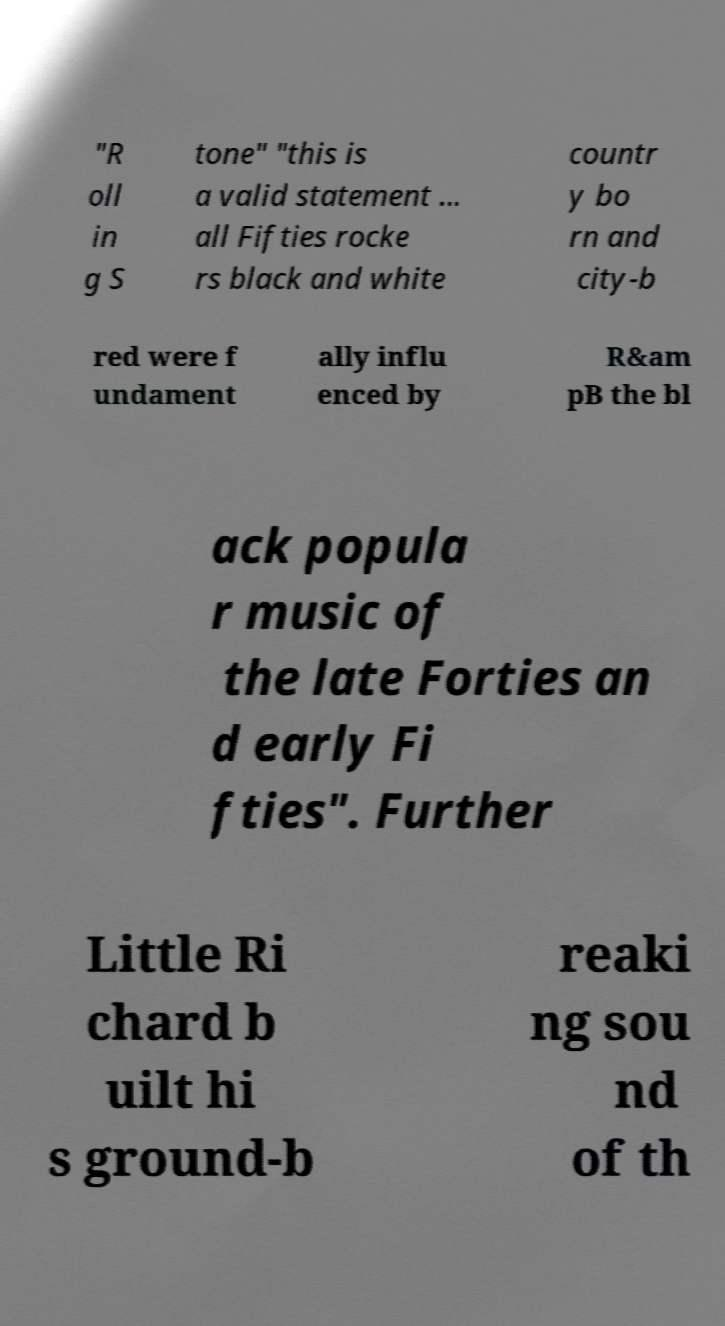Can you read and provide the text displayed in the image?This photo seems to have some interesting text. Can you extract and type it out for me? "R oll in g S tone" "this is a valid statement ... all Fifties rocke rs black and white countr y bo rn and city-b red were f undament ally influ enced by R&am pB the bl ack popula r music of the late Forties an d early Fi fties". Further Little Ri chard b uilt hi s ground-b reaki ng sou nd of th 